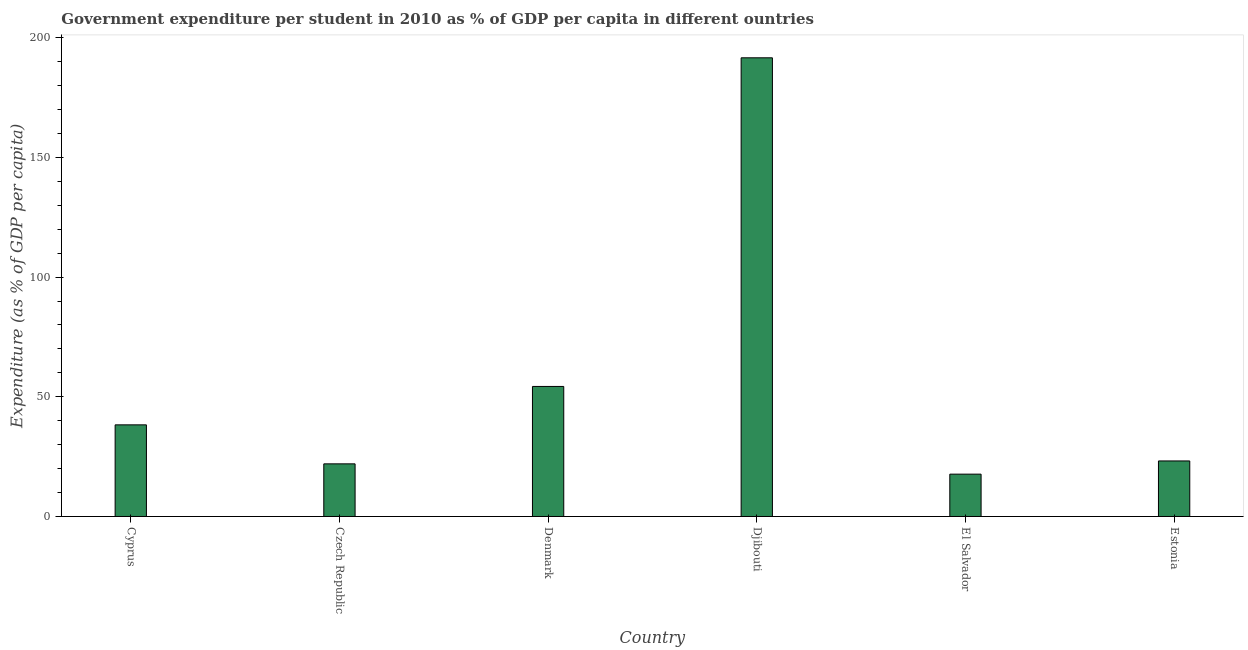What is the title of the graph?
Make the answer very short. Government expenditure per student in 2010 as % of GDP per capita in different ountries. What is the label or title of the X-axis?
Provide a short and direct response. Country. What is the label or title of the Y-axis?
Give a very brief answer. Expenditure (as % of GDP per capita). What is the government expenditure per student in El Salvador?
Offer a very short reply. 17.68. Across all countries, what is the maximum government expenditure per student?
Keep it short and to the point. 191.6. Across all countries, what is the minimum government expenditure per student?
Give a very brief answer. 17.68. In which country was the government expenditure per student maximum?
Make the answer very short. Djibouti. In which country was the government expenditure per student minimum?
Your response must be concise. El Salvador. What is the sum of the government expenditure per student?
Your answer should be compact. 347.07. What is the difference between the government expenditure per student in Cyprus and Estonia?
Offer a terse response. 15.07. What is the average government expenditure per student per country?
Your answer should be very brief. 57.84. What is the median government expenditure per student?
Provide a short and direct response. 30.74. What is the ratio of the government expenditure per student in Denmark to that in El Salvador?
Give a very brief answer. 3.07. Is the difference between the government expenditure per student in El Salvador and Estonia greater than the difference between any two countries?
Give a very brief answer. No. What is the difference between the highest and the second highest government expenditure per student?
Provide a succinct answer. 137.28. What is the difference between the highest and the lowest government expenditure per student?
Your response must be concise. 173.91. How many bars are there?
Your response must be concise. 6. Are all the bars in the graph horizontal?
Ensure brevity in your answer.  No. How many countries are there in the graph?
Offer a very short reply. 6. Are the values on the major ticks of Y-axis written in scientific E-notation?
Make the answer very short. No. What is the Expenditure (as % of GDP per capita) in Cyprus?
Provide a short and direct response. 38.28. What is the Expenditure (as % of GDP per capita) in Czech Republic?
Your answer should be very brief. 21.98. What is the Expenditure (as % of GDP per capita) of Denmark?
Provide a short and direct response. 54.32. What is the Expenditure (as % of GDP per capita) in Djibouti?
Ensure brevity in your answer.  191.6. What is the Expenditure (as % of GDP per capita) of El Salvador?
Provide a succinct answer. 17.68. What is the Expenditure (as % of GDP per capita) in Estonia?
Keep it short and to the point. 23.2. What is the difference between the Expenditure (as % of GDP per capita) in Cyprus and Czech Republic?
Your answer should be very brief. 16.29. What is the difference between the Expenditure (as % of GDP per capita) in Cyprus and Denmark?
Ensure brevity in your answer.  -16.04. What is the difference between the Expenditure (as % of GDP per capita) in Cyprus and Djibouti?
Ensure brevity in your answer.  -153.32. What is the difference between the Expenditure (as % of GDP per capita) in Cyprus and El Salvador?
Your answer should be very brief. 20.59. What is the difference between the Expenditure (as % of GDP per capita) in Cyprus and Estonia?
Ensure brevity in your answer.  15.07. What is the difference between the Expenditure (as % of GDP per capita) in Czech Republic and Denmark?
Ensure brevity in your answer.  -32.34. What is the difference between the Expenditure (as % of GDP per capita) in Czech Republic and Djibouti?
Your answer should be compact. -169.61. What is the difference between the Expenditure (as % of GDP per capita) in Czech Republic and El Salvador?
Give a very brief answer. 4.3. What is the difference between the Expenditure (as % of GDP per capita) in Czech Republic and Estonia?
Your answer should be very brief. -1.22. What is the difference between the Expenditure (as % of GDP per capita) in Denmark and Djibouti?
Your response must be concise. -137.28. What is the difference between the Expenditure (as % of GDP per capita) in Denmark and El Salvador?
Your response must be concise. 36.64. What is the difference between the Expenditure (as % of GDP per capita) in Denmark and Estonia?
Provide a short and direct response. 31.12. What is the difference between the Expenditure (as % of GDP per capita) in Djibouti and El Salvador?
Your response must be concise. 173.91. What is the difference between the Expenditure (as % of GDP per capita) in Djibouti and Estonia?
Your answer should be very brief. 168.4. What is the difference between the Expenditure (as % of GDP per capita) in El Salvador and Estonia?
Your response must be concise. -5.52. What is the ratio of the Expenditure (as % of GDP per capita) in Cyprus to that in Czech Republic?
Provide a short and direct response. 1.74. What is the ratio of the Expenditure (as % of GDP per capita) in Cyprus to that in Denmark?
Offer a terse response. 0.7. What is the ratio of the Expenditure (as % of GDP per capita) in Cyprus to that in Djibouti?
Your response must be concise. 0.2. What is the ratio of the Expenditure (as % of GDP per capita) in Cyprus to that in El Salvador?
Make the answer very short. 2.16. What is the ratio of the Expenditure (as % of GDP per capita) in Cyprus to that in Estonia?
Keep it short and to the point. 1.65. What is the ratio of the Expenditure (as % of GDP per capita) in Czech Republic to that in Denmark?
Keep it short and to the point. 0.41. What is the ratio of the Expenditure (as % of GDP per capita) in Czech Republic to that in Djibouti?
Offer a terse response. 0.12. What is the ratio of the Expenditure (as % of GDP per capita) in Czech Republic to that in El Salvador?
Your answer should be compact. 1.24. What is the ratio of the Expenditure (as % of GDP per capita) in Czech Republic to that in Estonia?
Offer a terse response. 0.95. What is the ratio of the Expenditure (as % of GDP per capita) in Denmark to that in Djibouti?
Offer a terse response. 0.28. What is the ratio of the Expenditure (as % of GDP per capita) in Denmark to that in El Salvador?
Provide a succinct answer. 3.07. What is the ratio of the Expenditure (as % of GDP per capita) in Denmark to that in Estonia?
Provide a succinct answer. 2.34. What is the ratio of the Expenditure (as % of GDP per capita) in Djibouti to that in El Salvador?
Your answer should be compact. 10.84. What is the ratio of the Expenditure (as % of GDP per capita) in Djibouti to that in Estonia?
Keep it short and to the point. 8.26. What is the ratio of the Expenditure (as % of GDP per capita) in El Salvador to that in Estonia?
Provide a short and direct response. 0.76. 